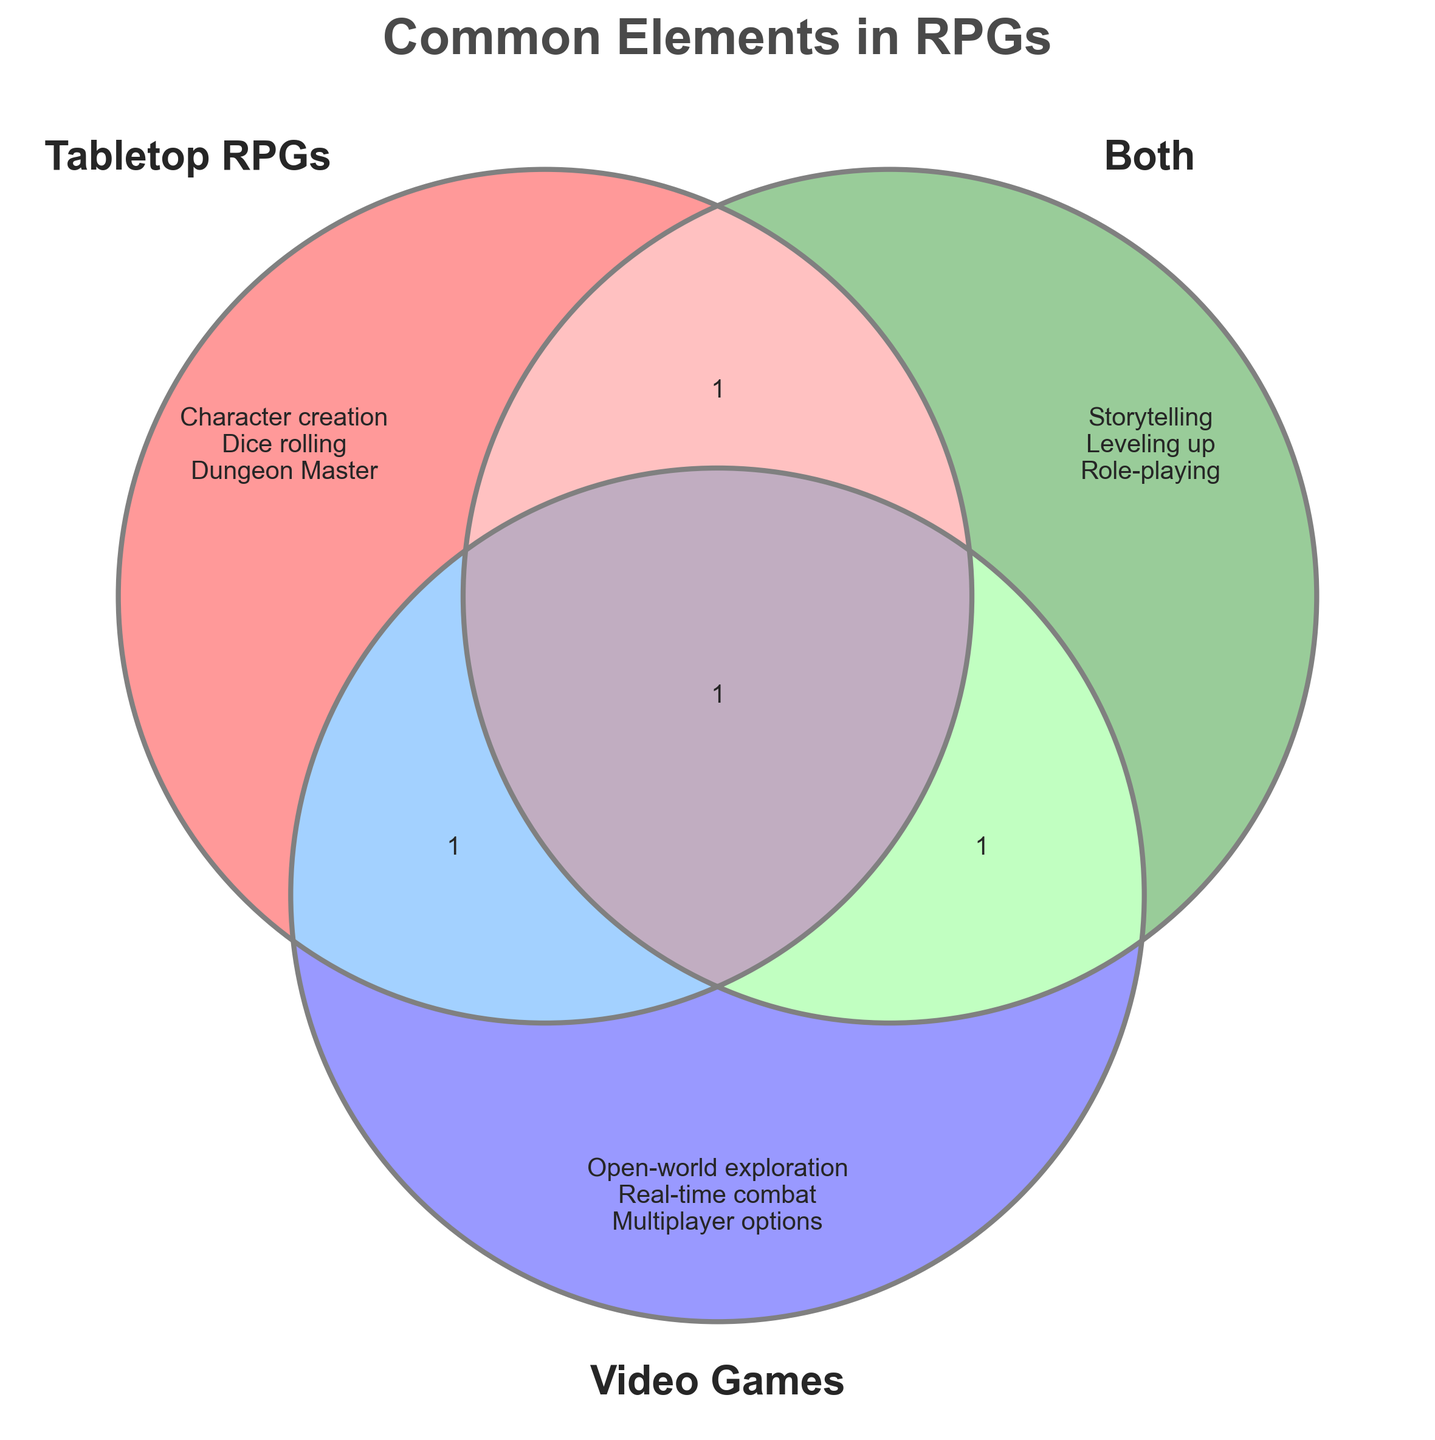What elements are common between tabletop RPGs and video games? The "Both" section in the Venn Diagram contains the elements that are common between tabletop RPGs and video games. These elements are storytelling, leveling up, and role-playing.
Answer: storytelling, leveling up, role-playing Which set of RPGs includes 'Character creation'? 'Character creation' is listed under the "Tabletop RPGs" section of the Venn Diagram.
Answer: Tabletop RPGs How many elements are unique to video games? The "Video Games" section contains three unique elements: open-world exploration, real-time combat, and multiplayer options.
Answer: 3 Are 'rulebooks' and 'quests' shared between tabletop RPGs and video games? No, both 'rulebooks' and 'quests' are listed under "Tabletop RPGs" and are not shared with video games.
Answer: No Which category is 'inventory management' in? 'Inventory management' is listed under the "Both" section of the Venn Diagram.
Answer: Both How many elements are not shared by any other category? Each section (Tabletop RPGs, Both, Video Games) contains three elements that are unique to themselves, totaling nine unique elements.
Answer: 9 Is 'multiplayer options' exclusive to video games? Yes, 'multiplayer options' is listed under the "Video Games" section and is not shared with tabletop RPGs or both.
Answer: Yes What differentiates tabletop RPGs and video games based on their unique elements? Tabletop RPGs have elements like character creation, dice rolling, and dungeon master, while video games have elements like open-world exploration, real-time combat, and multiplayer options.
Answer: Tabletop RPGs: character creation, dice rolling, dungeon master; Video games: open-world exploration, real-time combat, multiplayer options List all elements found only in the 'Both' section of the diagram. The elements exclusive to the "Both" section are storytelling, leveling up, and role-playing.
Answer: storytelling, leveling up, role-playing Which section has 'graphics engines' and how many elements are listed in that section? 'Graphics engines' are listed in the "Video Games" section, which has three elements.
Answer: Video Games; 3 